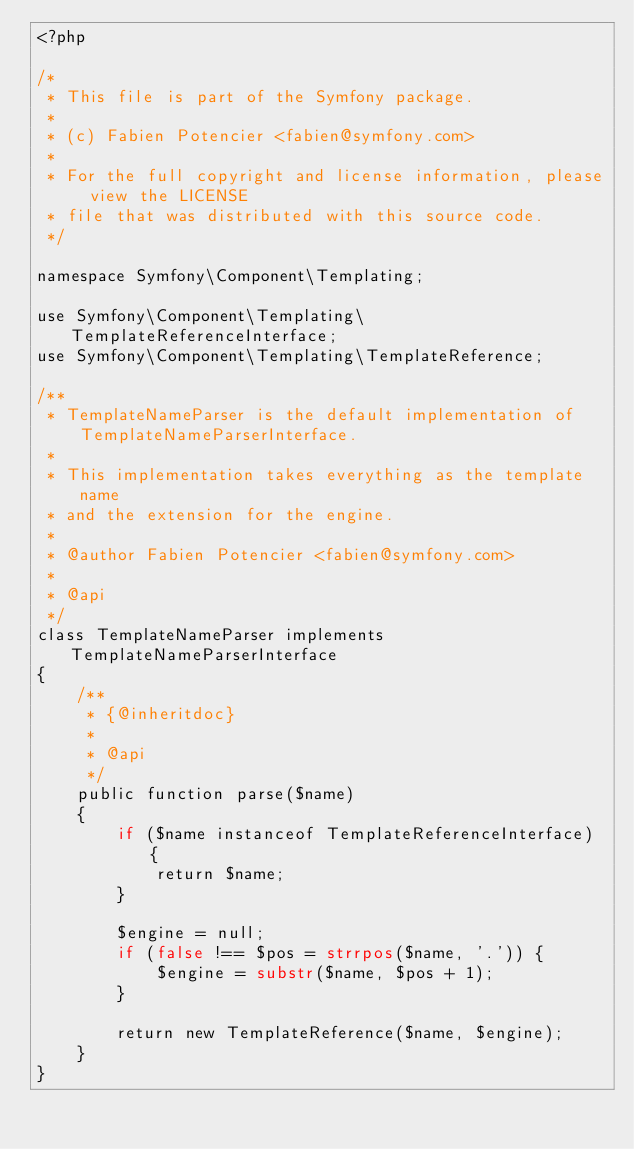<code> <loc_0><loc_0><loc_500><loc_500><_PHP_><?php

/*
 * This file is part of the Symfony package.
 *
 * (c) Fabien Potencier <fabien@symfony.com>
 *
 * For the full copyright and license information, please view the LICENSE
 * file that was distributed with this source code.
 */

namespace Symfony\Component\Templating;

use Symfony\Component\Templating\TemplateReferenceInterface;
use Symfony\Component\Templating\TemplateReference;

/**
 * TemplateNameParser is the default implementation of TemplateNameParserInterface.
 *
 * This implementation takes everything as the template name
 * and the extension for the engine.
 *
 * @author Fabien Potencier <fabien@symfony.com>
 *
 * @api
 */
class TemplateNameParser implements TemplateNameParserInterface
{
    /**
     * {@inheritdoc}
     *
     * @api
     */
    public function parse($name)
    {
        if ($name instanceof TemplateReferenceInterface) {
            return $name;
        }

        $engine = null;
        if (false !== $pos = strrpos($name, '.')) {
            $engine = substr($name, $pos + 1);
        }

        return new TemplateReference($name, $engine);
    }
}
</code> 